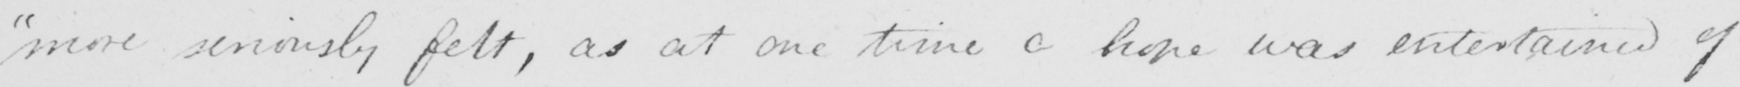What does this handwritten line say? more seriously felt , as at one time a hope was entertained of 